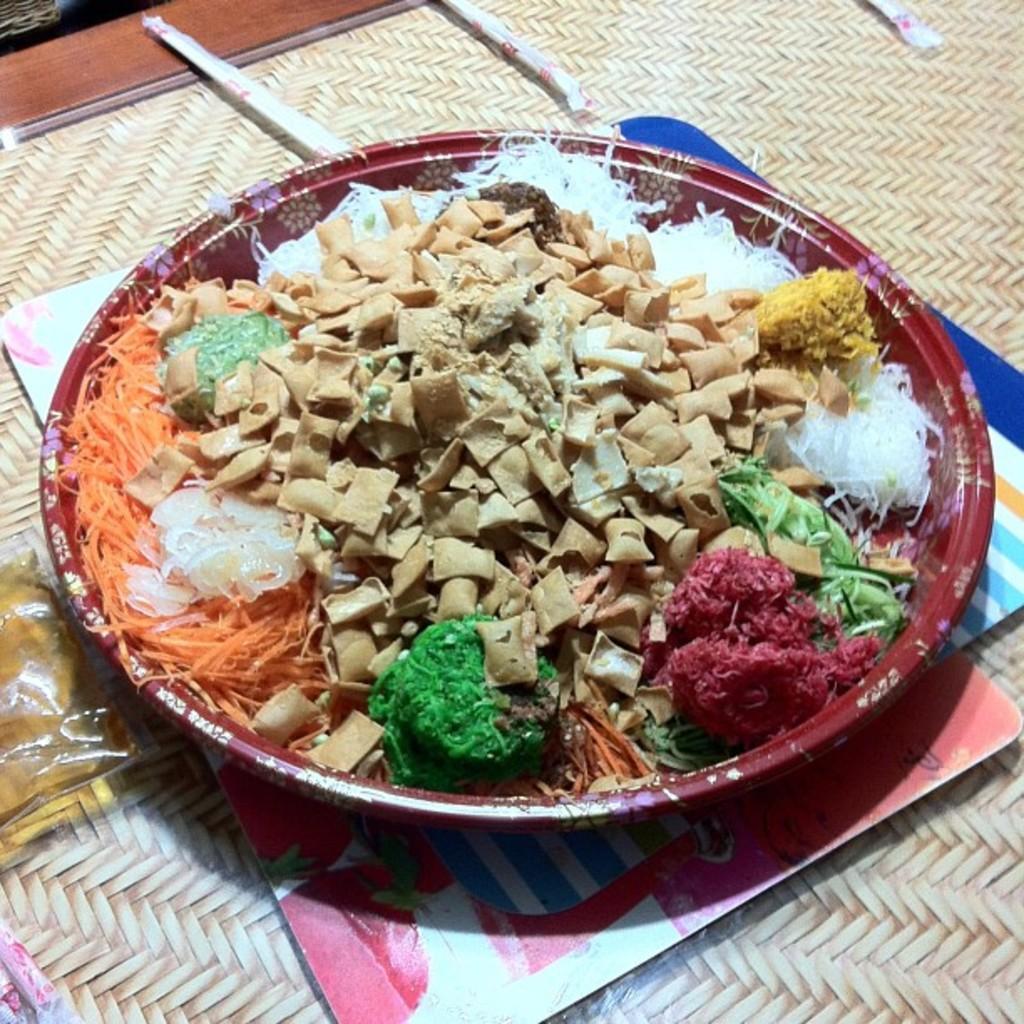Describe this image in one or two sentences. In this image there is a plate on which there are chips,carrot slices and some food in it. The plate is kept on the mat. On the left side there is a packet beside the plate. 